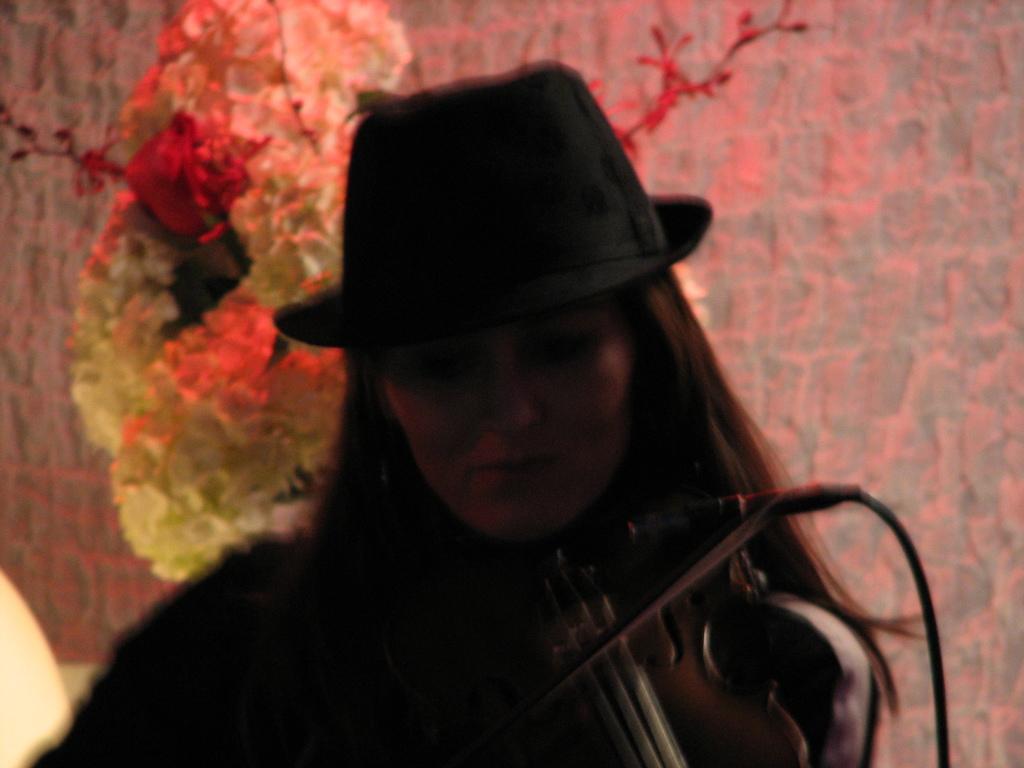Describe this image in one or two sentences. In this image I can see a woman with musical instrument. I can see she is wearing a hat. 